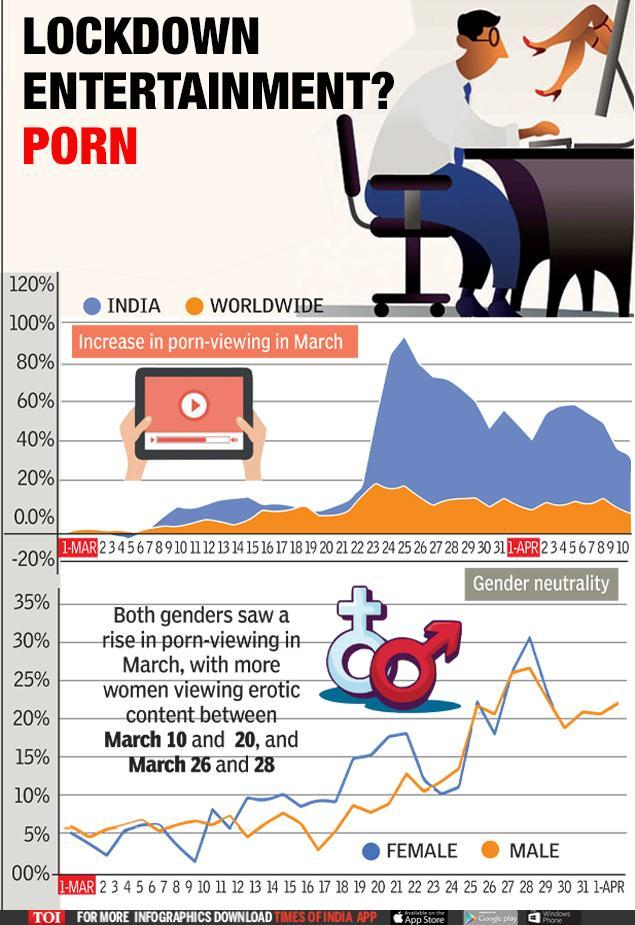Which color is used to represent Worldwide- blue, orange, or white?
Answer the question with a short phrase. orange Which color is used to represent female- orange, blue, or white? blue Which color is used to represent male- blue, orange, or white? orange Which color is used to represent India- orange, blue, or white? blue 